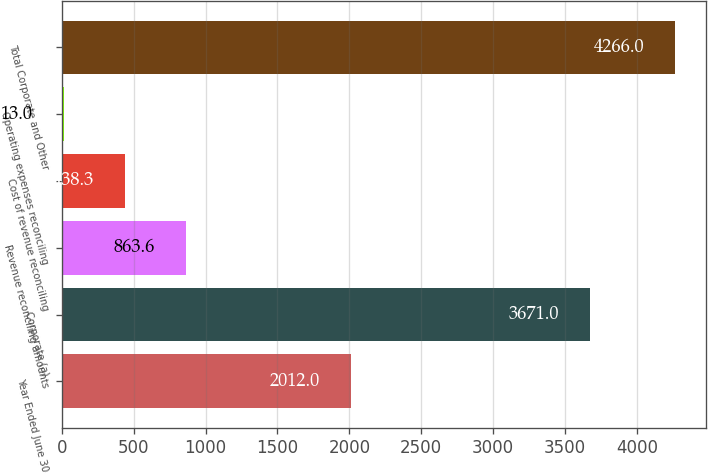<chart> <loc_0><loc_0><loc_500><loc_500><bar_chart><fcel>Year Ended June 30<fcel>Corporate (a)<fcel>Revenue reconciling amounts<fcel>Cost of revenue reconciling<fcel>Operating expenses reconciling<fcel>Total Corporate and Other<nl><fcel>2012<fcel>3671<fcel>863.6<fcel>438.3<fcel>13<fcel>4266<nl></chart> 